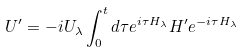<formula> <loc_0><loc_0><loc_500><loc_500>U ^ { \prime } = - i U _ { \lambda } \int _ { 0 } ^ { t } d \tau e ^ { i \tau H _ { \lambda } } H ^ { \prime } e ^ { - i \tau H _ { \lambda } }</formula> 